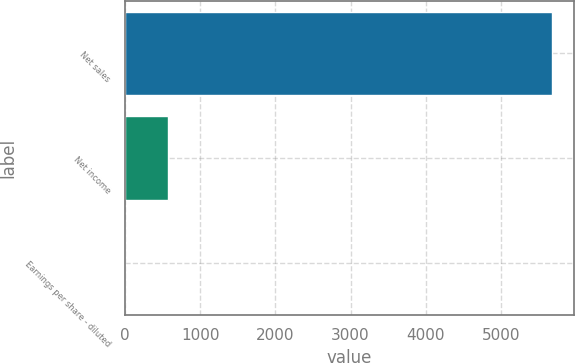Convert chart. <chart><loc_0><loc_0><loc_500><loc_500><bar_chart><fcel>Net sales<fcel>Net income<fcel>Earnings per share - diluted<nl><fcel>5682<fcel>568.34<fcel>0.15<nl></chart> 